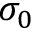Convert formula to latex. <formula><loc_0><loc_0><loc_500><loc_500>\sigma _ { 0 }</formula> 